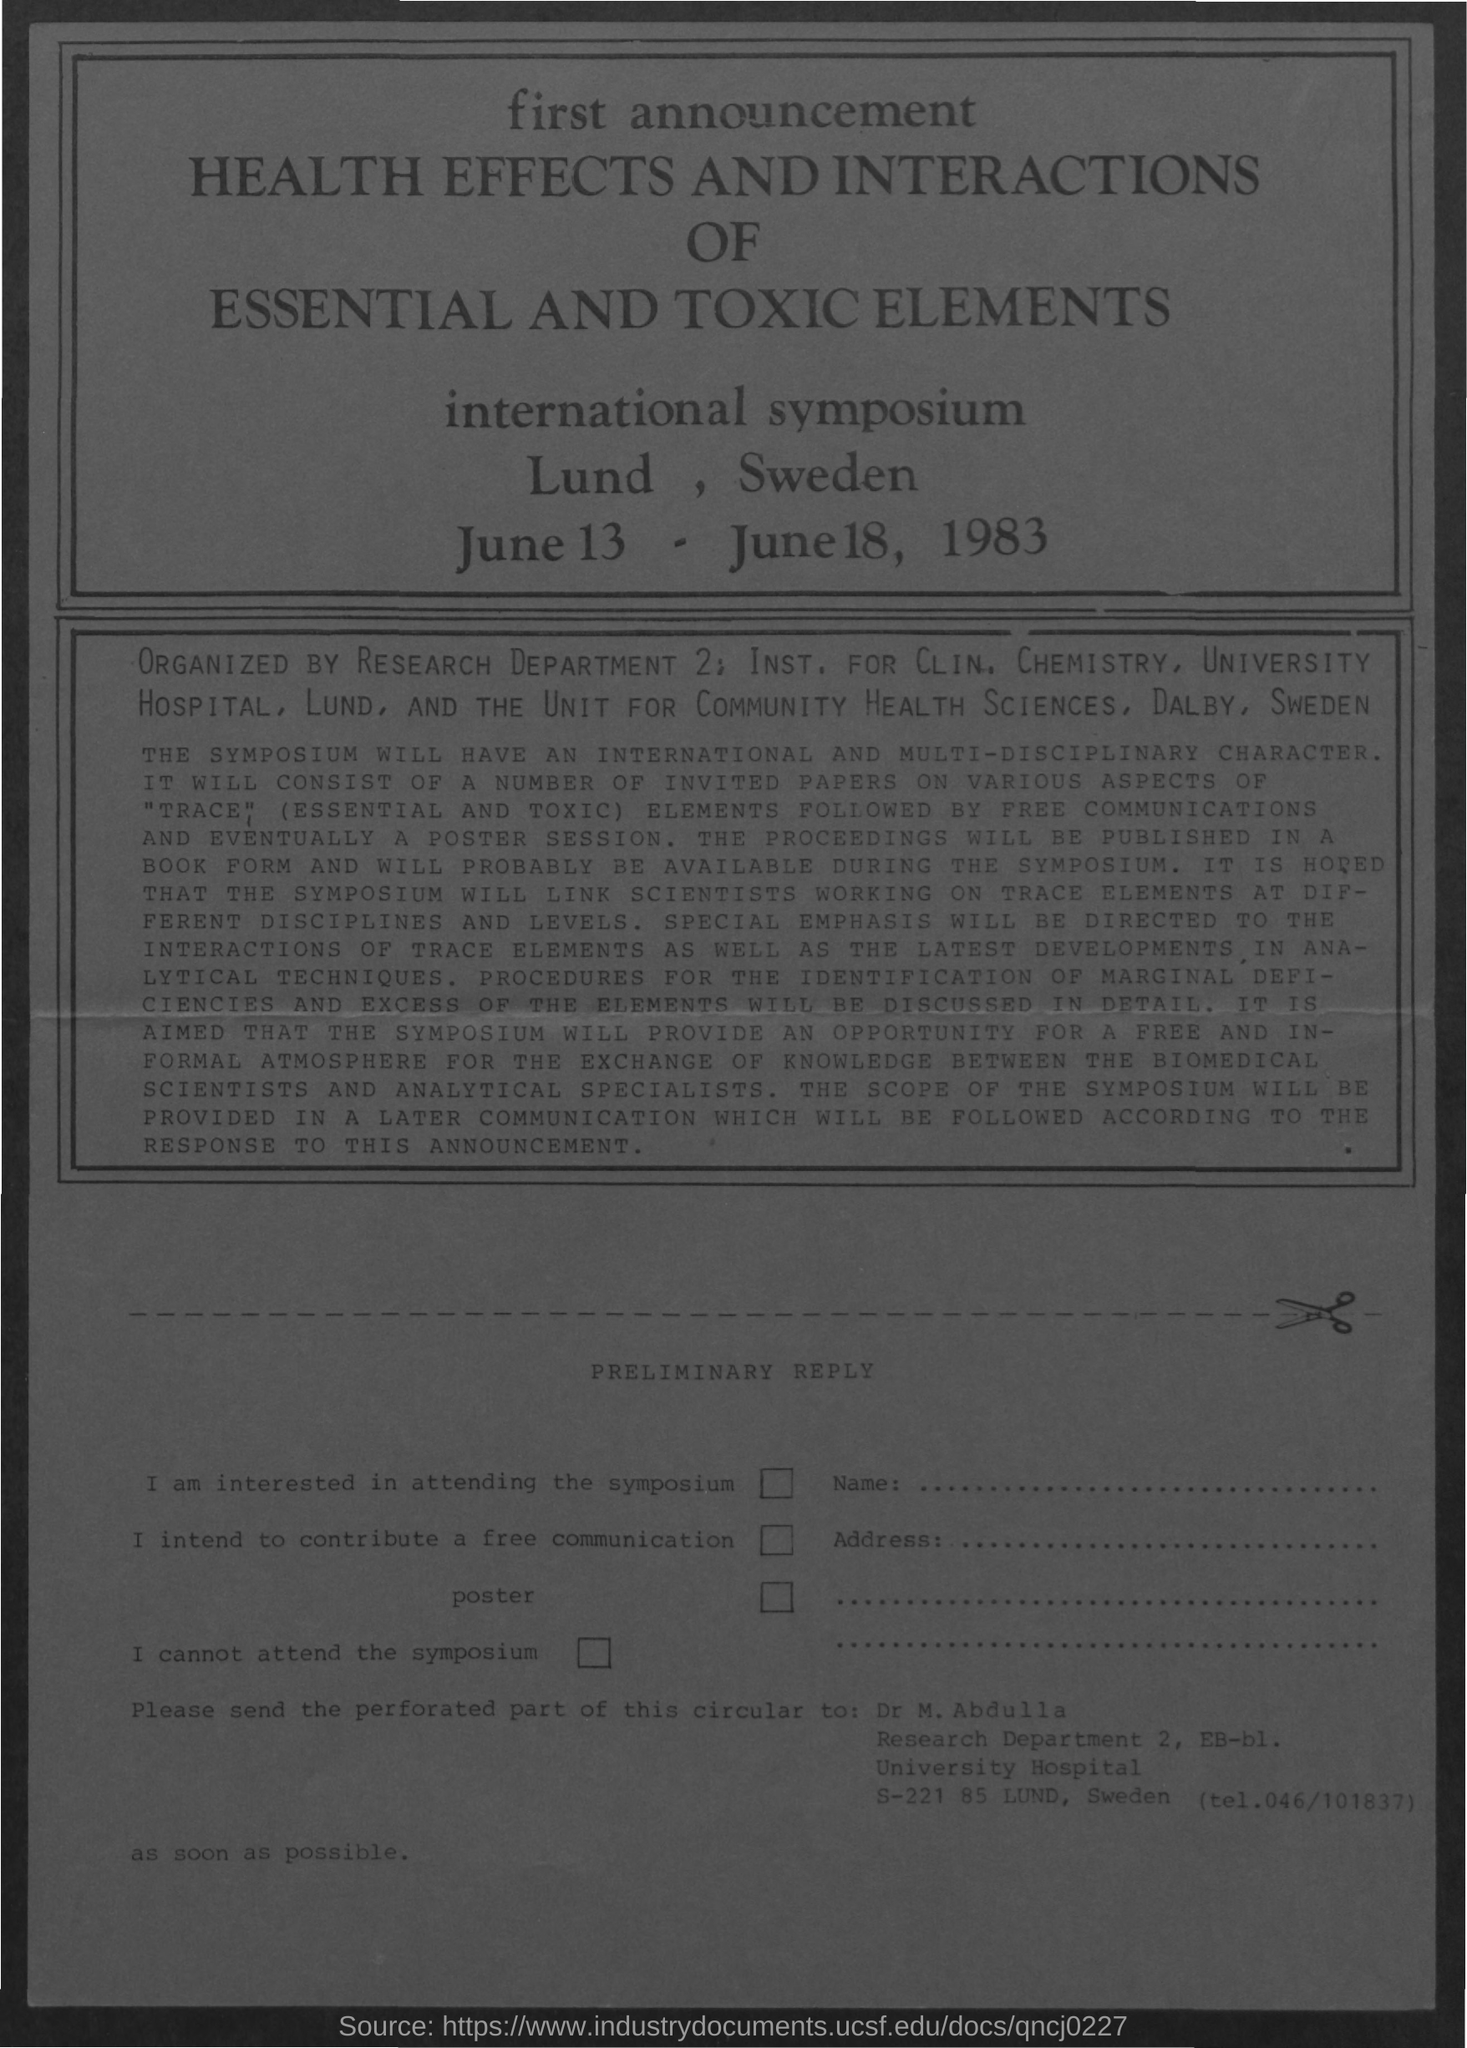What is the date mentioned?
Give a very brief answer. June 13 - June 18, 1983. What is the main heading of the document?
Your answer should be compact. Health Effects and Interactions of Essential and Toxic Elements. 